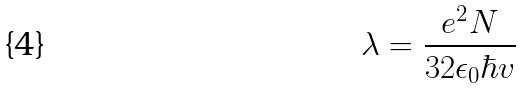<formula> <loc_0><loc_0><loc_500><loc_500>\lambda = \frac { e ^ { 2 } N } { 3 2 \epsilon _ { 0 } \hbar { v } }</formula> 